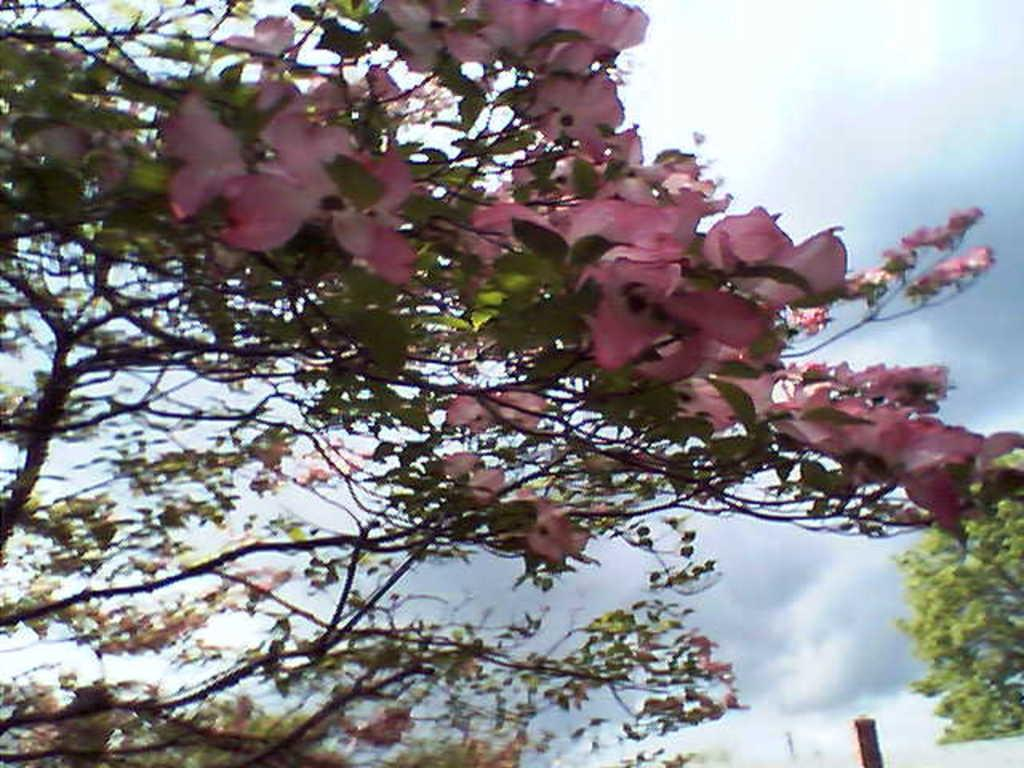What type of vegetation can be seen on a tree in the image? There are flowers on a tree in the image. What other types of vegetation are present in the image? There are other plants and trees present in the image. What is the condition of the sky in the image? The sky is fully covered with clouds in the image. Where is the mine located in the image? There is no mine present in the image. Can you tell me how many family members are visible in the image? There are no family members present in the image. How many lizards can be seen in the image? There are no lizards present in the image. 